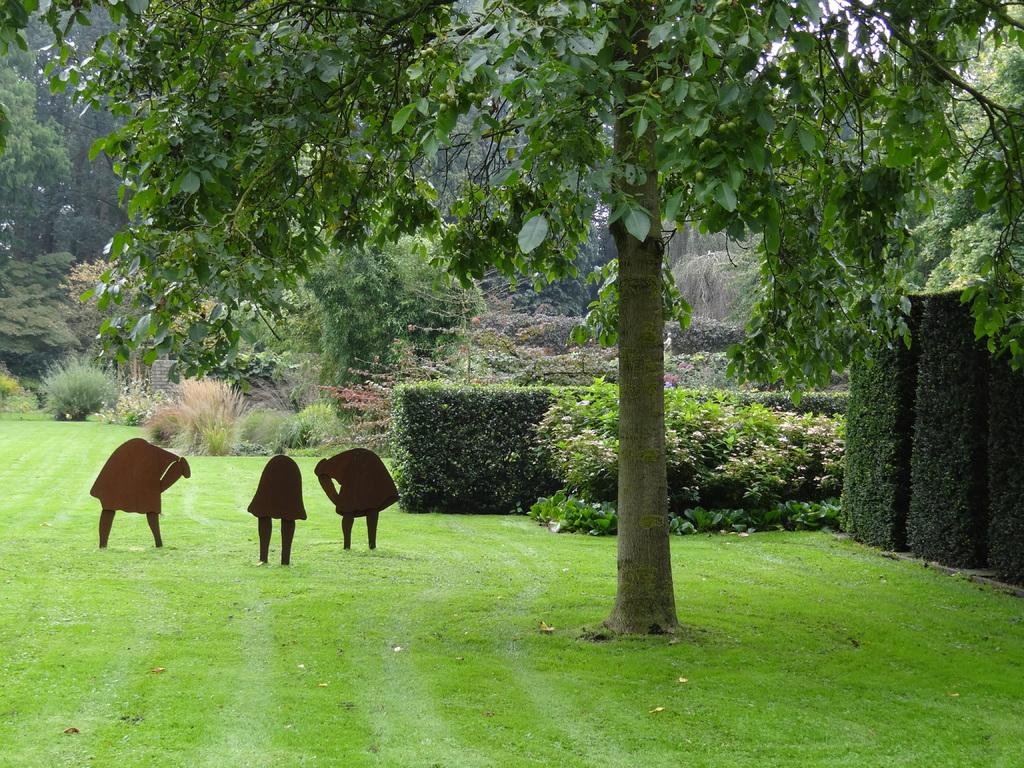What type of surface covers the ground in the image? The ground in the image is covered with grass. What can be found on the grass in the image? There are objects on the grass. What type of vegetation is present in the image? There are plants and trees in the image. What type of lock can be seen securing the toad in the image? There is no lock or toad present in the image. What game is being played in the image? There is no game being played in the image. 